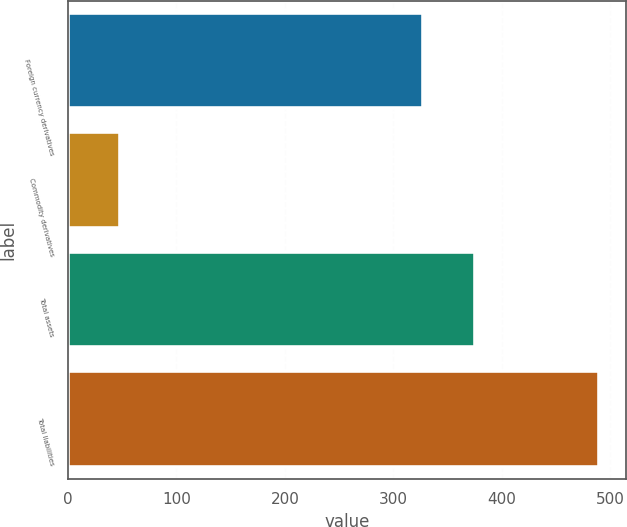Convert chart to OTSL. <chart><loc_0><loc_0><loc_500><loc_500><bar_chart><fcel>Foreign currency derivatives<fcel>Commodity derivatives<fcel>Total assets<fcel>Total liabilities<nl><fcel>327<fcel>48<fcel>375<fcel>490<nl></chart> 